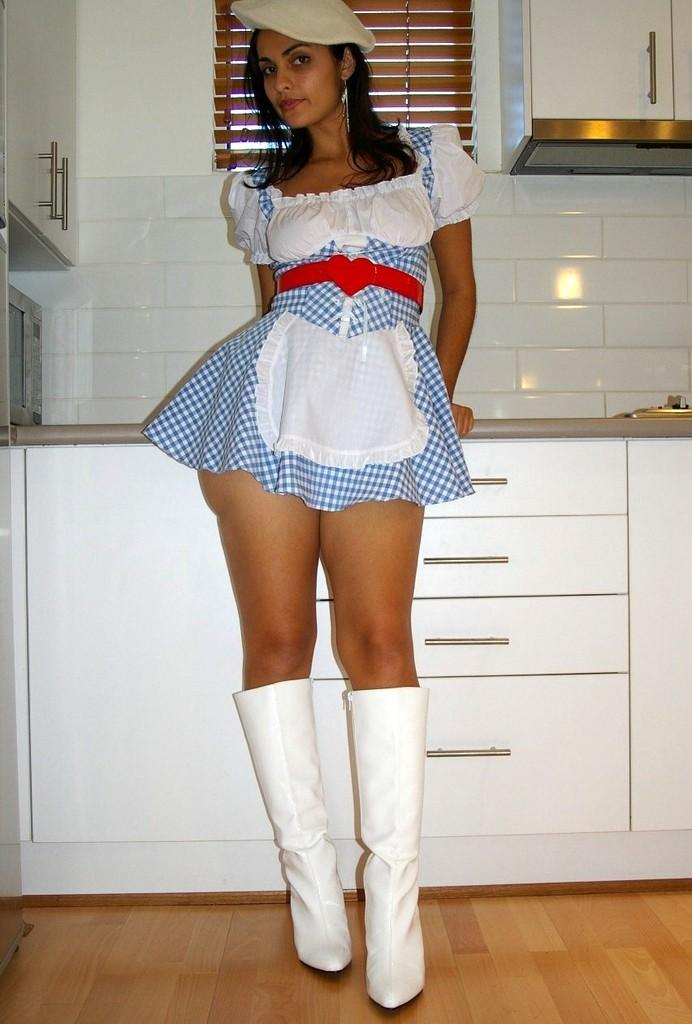What type of flooring is visible in the image? There are white color tiles in the image. What type of furniture can be seen in the image? There are cupboards in the image. Is there a person present in the image? Yes, there is a woman standing in the image. What type of cloth is the woman wearing in the image? The provided facts do not mention any clothing or fabric worn by the woman in the image. --- Facts: 1. There is a car in the image. 2. The car is red. 3. The car has four wheels. 4. There is a road in the image. 5. The road is paved. Absurd Topics: bird, ocean, mountain Conversation: What type of vehicle is in the image? There is a car in the image. What color is the car? The car is red. How many wheels does the car have? The car has four wheels. What type of surface is visible in the image? There is a road in the image, and it is paved. Reasoning: Let's think step by step in order to produce the conversation. We start by identifying the main subject in the image, which is the car. Then, we expand the conversation to include other details about the car, such as its color and the number of wheels. Finally, we describe the setting in which the car is located, mentioning the paved road. Each question is designed to elicit a specific detail about the image that is known from the provided facts. Absurd Question/Answer: Can you see any birds flying over the ocean in the image? The provided facts do not mention any birds or oceans in the image; it features a red car with four wheels on a paved road. 